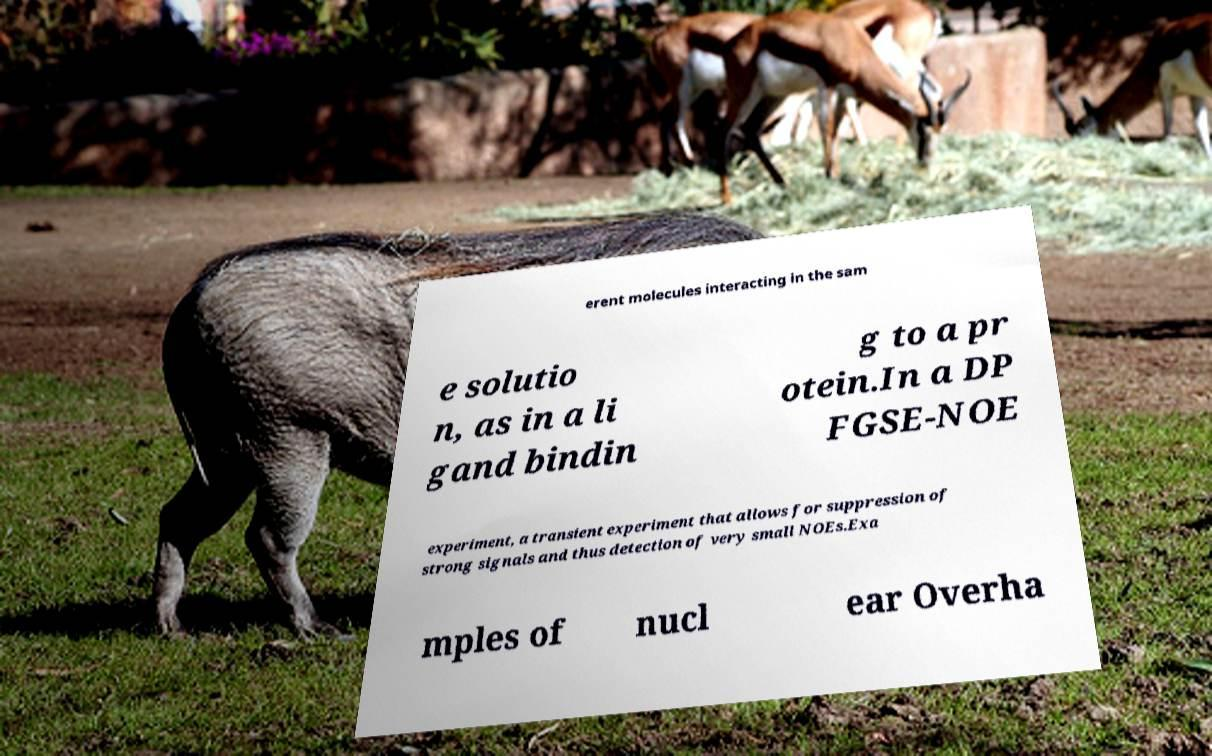I need the written content from this picture converted into text. Can you do that? erent molecules interacting in the sam e solutio n, as in a li gand bindin g to a pr otein.In a DP FGSE-NOE experiment, a transient experiment that allows for suppression of strong signals and thus detection of very small NOEs.Exa mples of nucl ear Overha 